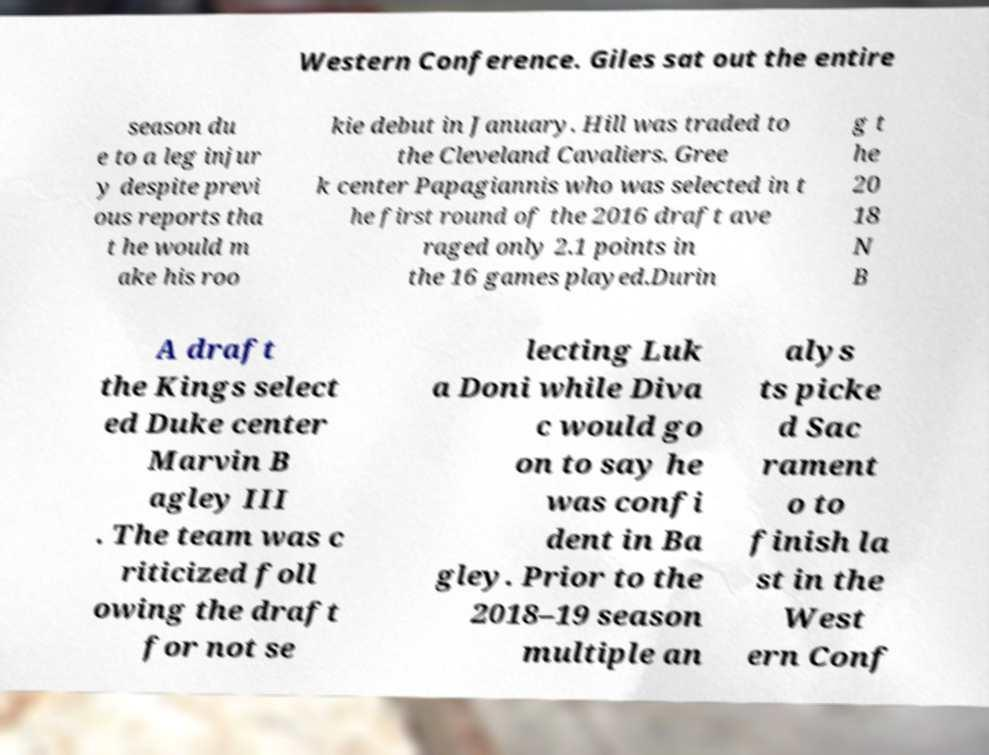Can you read and provide the text displayed in the image?This photo seems to have some interesting text. Can you extract and type it out for me? Western Conference. Giles sat out the entire season du e to a leg injur y despite previ ous reports tha t he would m ake his roo kie debut in January. Hill was traded to the Cleveland Cavaliers. Gree k center Papagiannis who was selected in t he first round of the 2016 draft ave raged only 2.1 points in the 16 games played.Durin g t he 20 18 N B A draft the Kings select ed Duke center Marvin B agley III . The team was c riticized foll owing the draft for not se lecting Luk a Doni while Diva c would go on to say he was confi dent in Ba gley. Prior to the 2018–19 season multiple an alys ts picke d Sac rament o to finish la st in the West ern Conf 